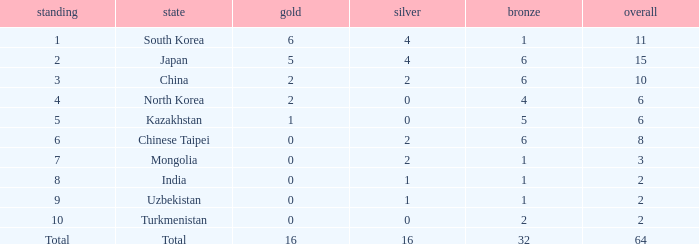What is the total Gold's less than 0? 0.0. 